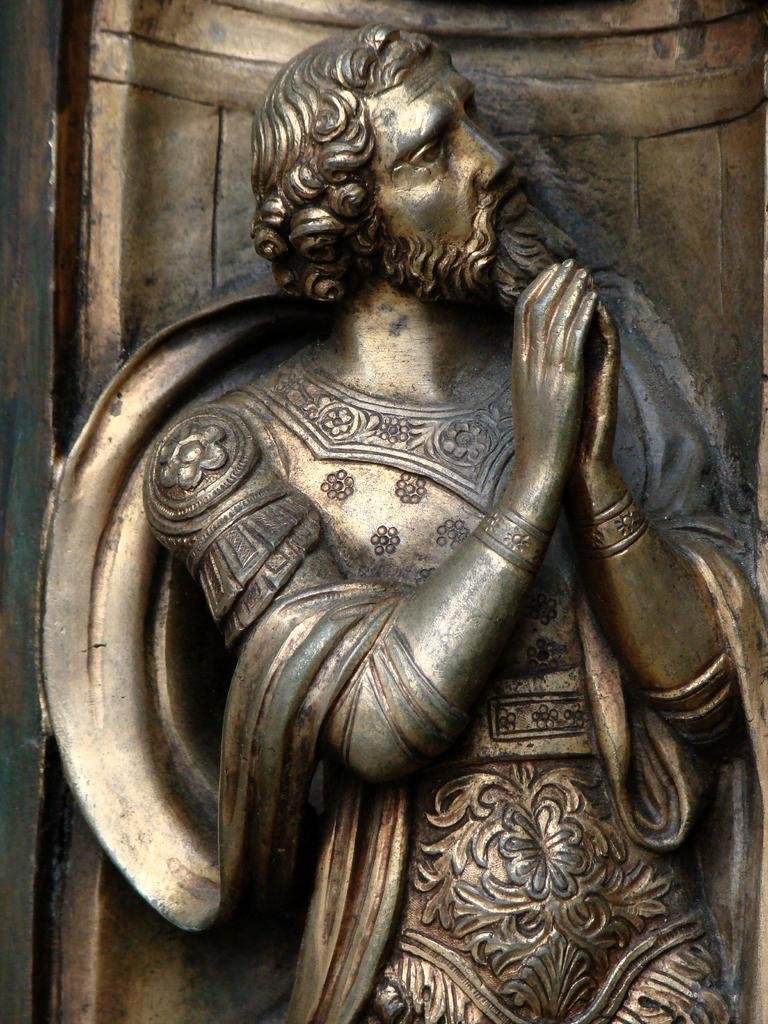What type of artwork is depicted in the image? The image is a sculpture. What subject is the sculpture representing? The sculpture is of a man. Can you tell me how many gravestones are present in the sculpture? There are no gravestones present in the sculpture; it is a sculpture of a man. What type of connection does the man have with the skate in the sculpture? There is no skate present in the sculpture; it is a sculpture of a man. 